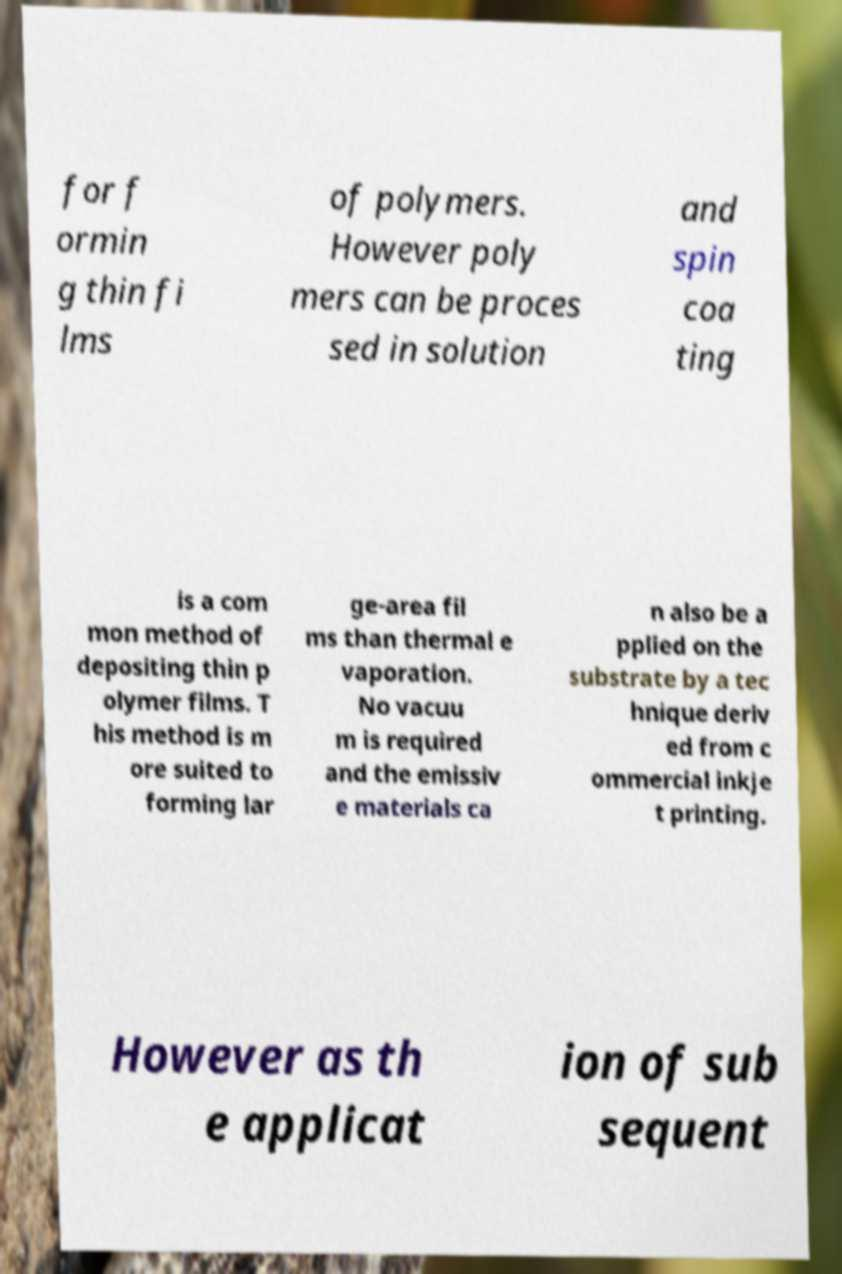What messages or text are displayed in this image? I need them in a readable, typed format. for f ormin g thin fi lms of polymers. However poly mers can be proces sed in solution and spin coa ting is a com mon method of depositing thin p olymer films. T his method is m ore suited to forming lar ge-area fil ms than thermal e vaporation. No vacuu m is required and the emissiv e materials ca n also be a pplied on the substrate by a tec hnique deriv ed from c ommercial inkje t printing. However as th e applicat ion of sub sequent 